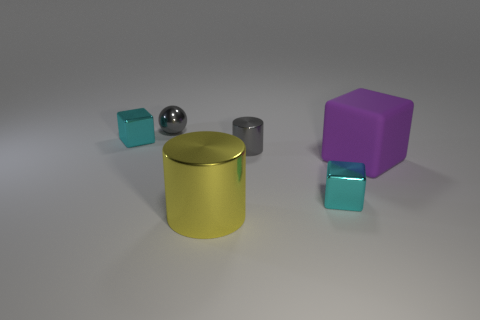What number of tiny cyan objects are on the right side of the gray cylinder that is behind the big purple rubber object? There is one tiny cyan cube situated to the right of the gray cylinder, which itself is placed behind the larger purple cube. 